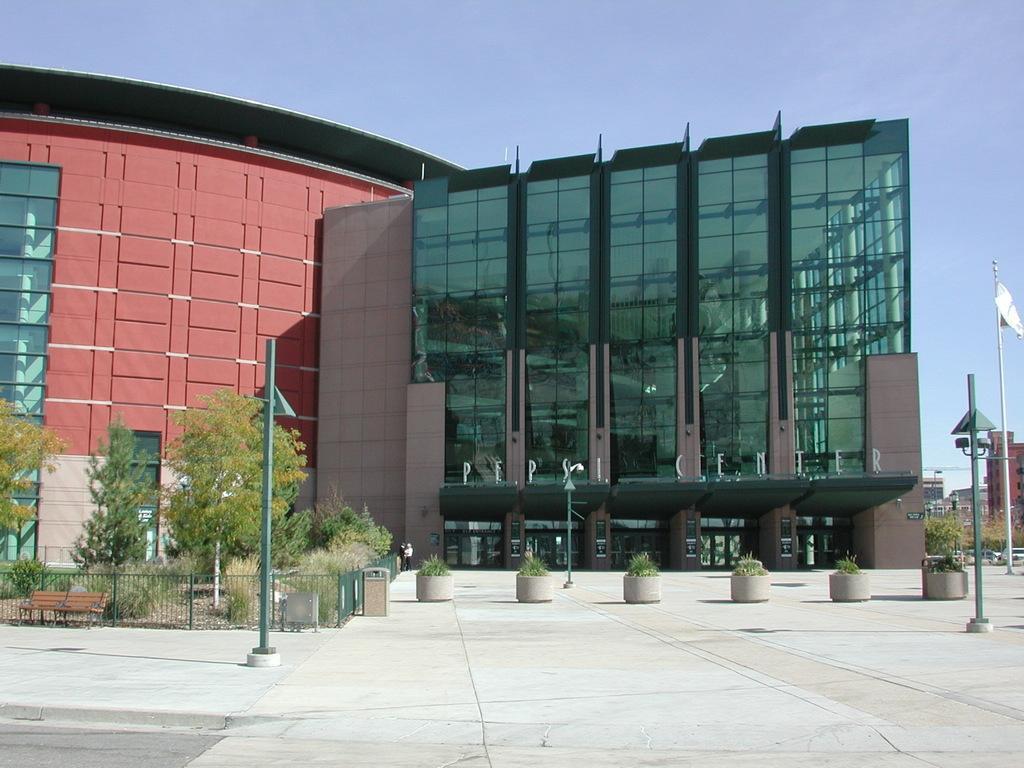Please provide a concise description of this image. On the left side, there is a pole on the road. On the right side, there is another pole on the road. In the background, there are potted plants arranged, there is a fence, beside this fence, there is a bench and there are plants on the ground, there are buildings which are having glass windows, there is a flag attached to a pole and there is blue sky. 